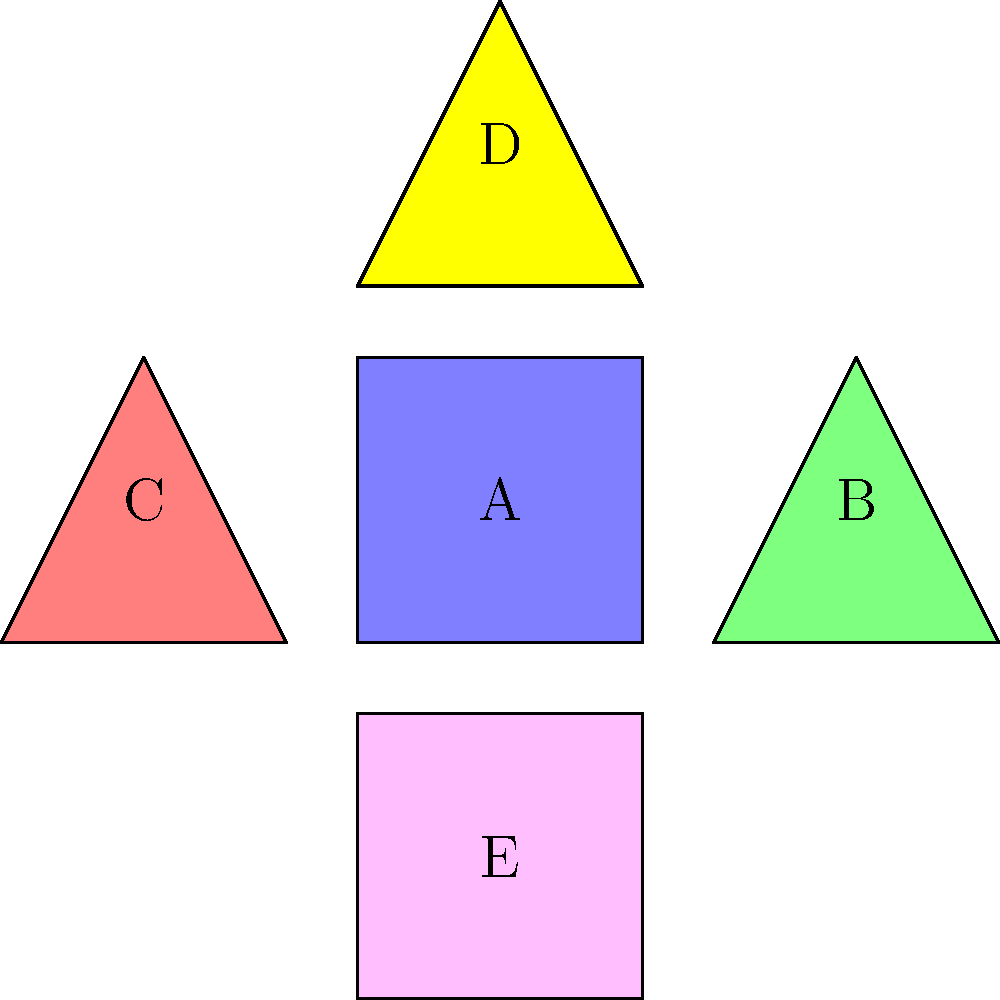Imagine you're playing with your younger sibling, and you've arranged toy blocks as shown in the diagram. Each shape represents a different character in your story. If the group action is rotation by 90 degrees clockwise, which cycle notation correctly represents the permutation of the characters after one rotation? Let's approach this step-by-step:

1. First, we need to understand what rotation by 90 degrees clockwise means. It means each shape will move to the position of the shape that was to its right (or below if it was the rightmost).

2. Let's follow each shape:
   - A (center blue square) stays in place
   - B (right green triangle) moves to where E was
   - C (left red triangle) moves to where D was
   - D (top yellow triangle) moves to where B was
   - E (bottom pink square) moves to where C was

3. In cycle notation, we write this as follows:
   - A forms a cycle by itself: (A)
   - The other shapes form a 4-cycle: B → E → C → D → B

4. When we combine these, we get: (A)(BECD)

5. Note that in cycle notation, we typically don't write 1-cycles like (A), so the final answer would just be (BECD).

This rotation creates a story where the characters (represented by the shapes) move in a circular pattern, with the central character staying put - perfect for an imaginative play scenario with a younger sibling!
Answer: (BECD) 